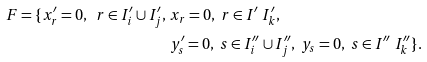Convert formula to latex. <formula><loc_0><loc_0><loc_500><loc_500>F = \{ x ^ { \prime } _ { r } = 0 , \ r \in I ^ { \prime } _ { i } \cup I ^ { \prime } _ { j } , & \ x _ { r } = 0 , \ r \in I ^ { \prime } \ I ^ { \prime } _ { k } , \\ & \ y ^ { \prime } _ { s } = 0 , \ s \in I ^ { \prime \prime } _ { i } \cup I ^ { \prime \prime } _ { j } , \ y _ { s } = 0 , \ s \in I ^ { \prime \prime } \ I ^ { \prime \prime } _ { k } \} .</formula> 